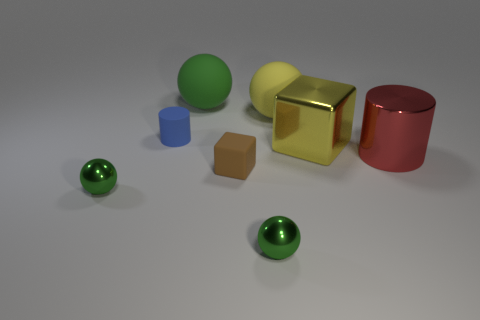Subtract all yellow matte balls. How many balls are left? 3 Add 1 big red objects. How many objects exist? 9 Subtract all yellow spheres. How many spheres are left? 3 Subtract all cubes. How many objects are left? 6 Subtract all green cylinders. How many yellow spheres are left? 1 Subtract all blue matte objects. Subtract all tiny brown objects. How many objects are left? 6 Add 7 big yellow cubes. How many big yellow cubes are left? 8 Add 2 big blue cylinders. How many big blue cylinders exist? 2 Subtract 0 green cylinders. How many objects are left? 8 Subtract 2 balls. How many balls are left? 2 